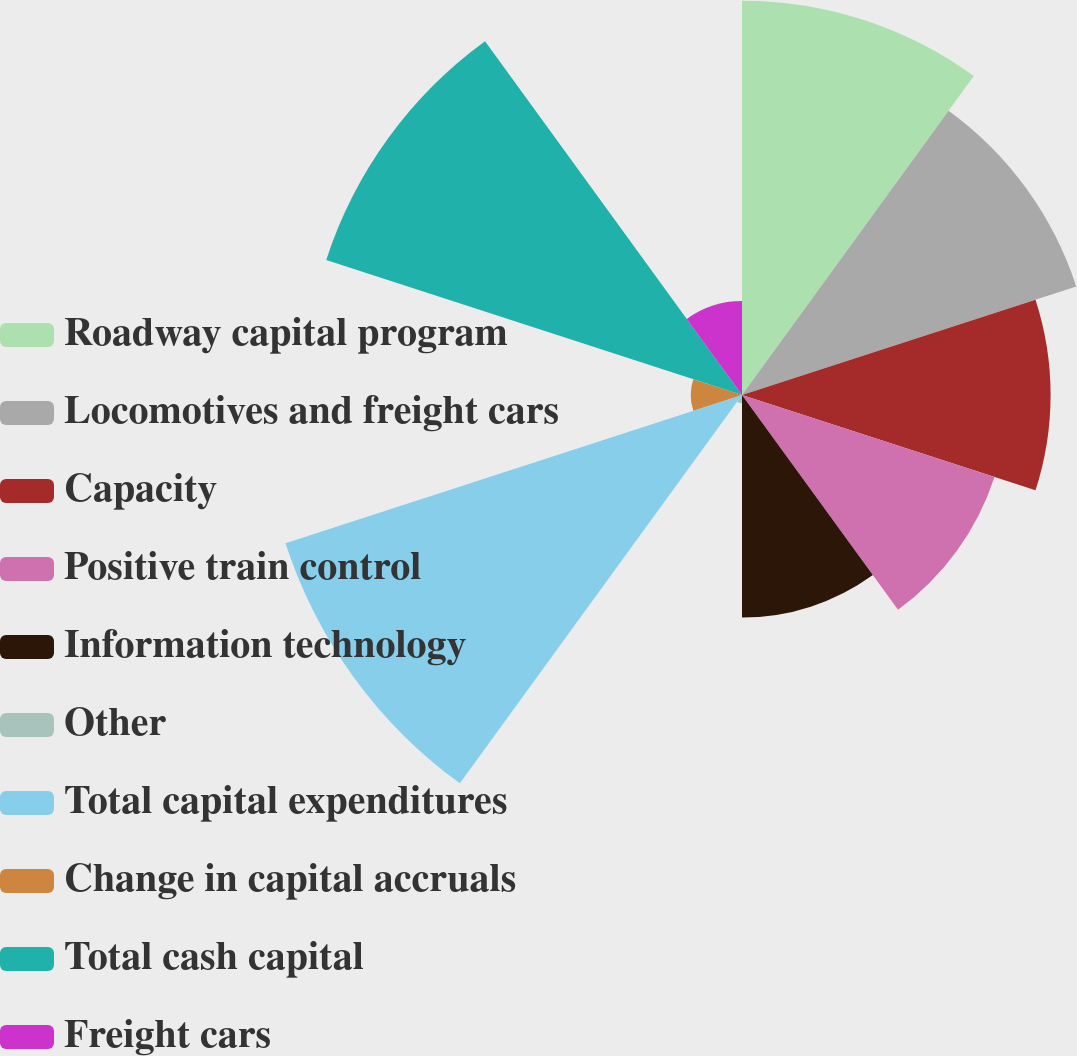<chart> <loc_0><loc_0><loc_500><loc_500><pie_chart><fcel>Roadway capital program<fcel>Locomotives and freight cars<fcel>Capacity<fcel>Positive train control<fcel>Information technology<fcel>Other<fcel>Total capital expenditures<fcel>Change in capital accruals<fcel>Total cash capital<fcel>Freight cars<nl><fcel>15.09%<fcel>13.45%<fcel>11.81%<fcel>10.16%<fcel>8.52%<fcel>0.32%<fcel>18.37%<fcel>1.96%<fcel>16.73%<fcel>3.6%<nl></chart> 